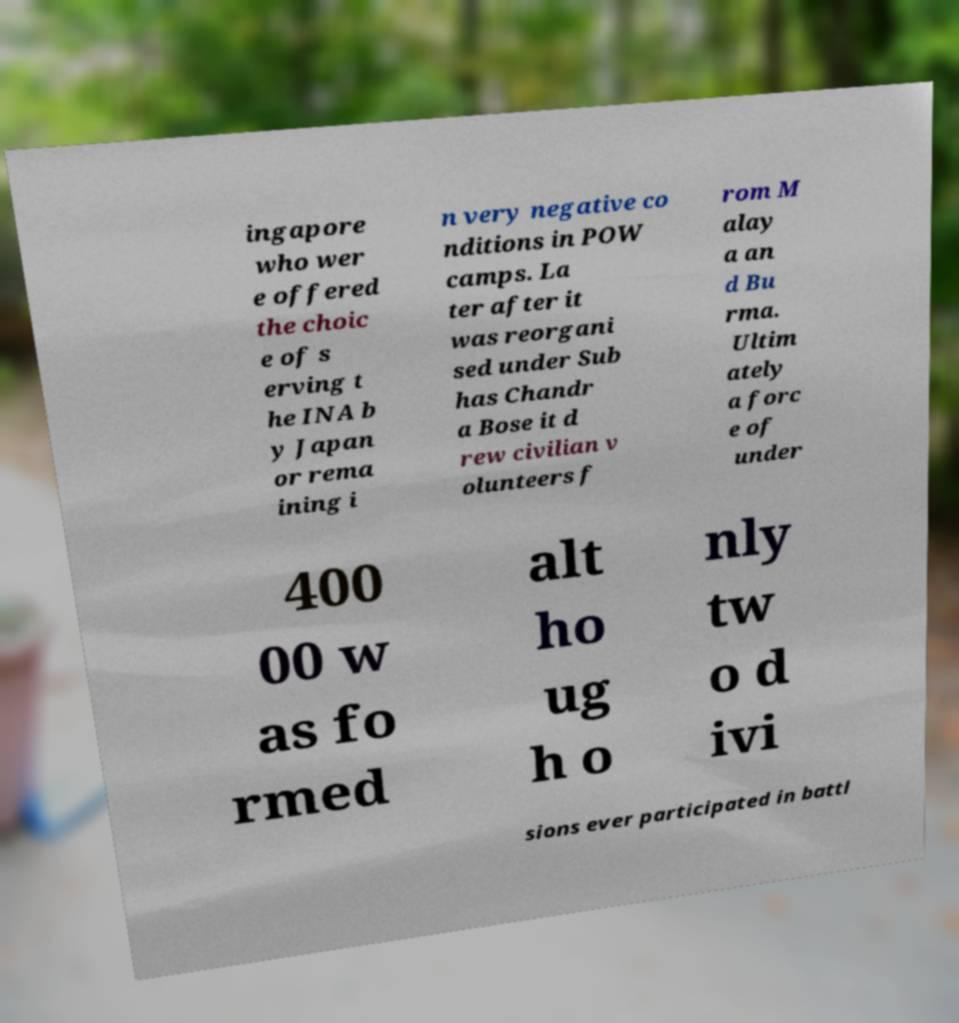Please read and relay the text visible in this image. What does it say? ingapore who wer e offered the choic e of s erving t he INA b y Japan or rema ining i n very negative co nditions in POW camps. La ter after it was reorgani sed under Sub has Chandr a Bose it d rew civilian v olunteers f rom M alay a an d Bu rma. Ultim ately a forc e of under 400 00 w as fo rmed alt ho ug h o nly tw o d ivi sions ever participated in battl 